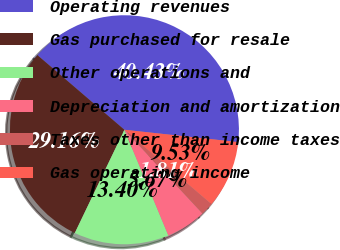<chart> <loc_0><loc_0><loc_500><loc_500><pie_chart><fcel>Operating revenues<fcel>Gas purchased for resale<fcel>Other operations and<fcel>Depreciation and amortization<fcel>Taxes other than income taxes<fcel>Gas operating income<nl><fcel>40.43%<fcel>29.16%<fcel>13.4%<fcel>5.67%<fcel>1.81%<fcel>9.53%<nl></chart> 